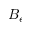Convert formula to latex. <formula><loc_0><loc_0><loc_500><loc_500>B _ { e }</formula> 